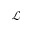<formula> <loc_0><loc_0><loc_500><loc_500>\mathcal { L }</formula> 